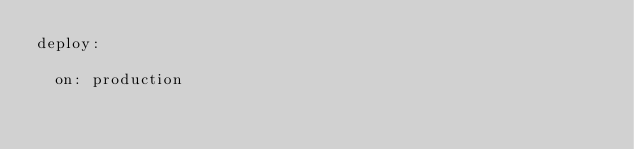<code> <loc_0><loc_0><loc_500><loc_500><_YAML_>deploy:

  on: production</code> 